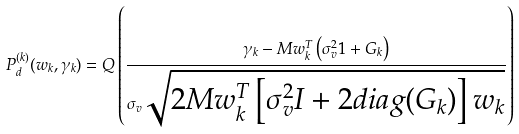<formula> <loc_0><loc_0><loc_500><loc_500>P _ { d } ^ { ( k ) } ( w _ { k } , \gamma _ { k } ) = Q \left ( \frac { \gamma _ { k } - M w _ { k } ^ { T } \left ( \sigma _ { v } ^ { 2 } 1 + G _ { k } \right ) } { \sigma _ { v } \sqrt { 2 M w _ { k } ^ { T } \left [ \sigma _ { v } ^ { 2 } I + 2 d i a g ( G _ { k } ) \right ] w _ { k } } } \right )</formula> 